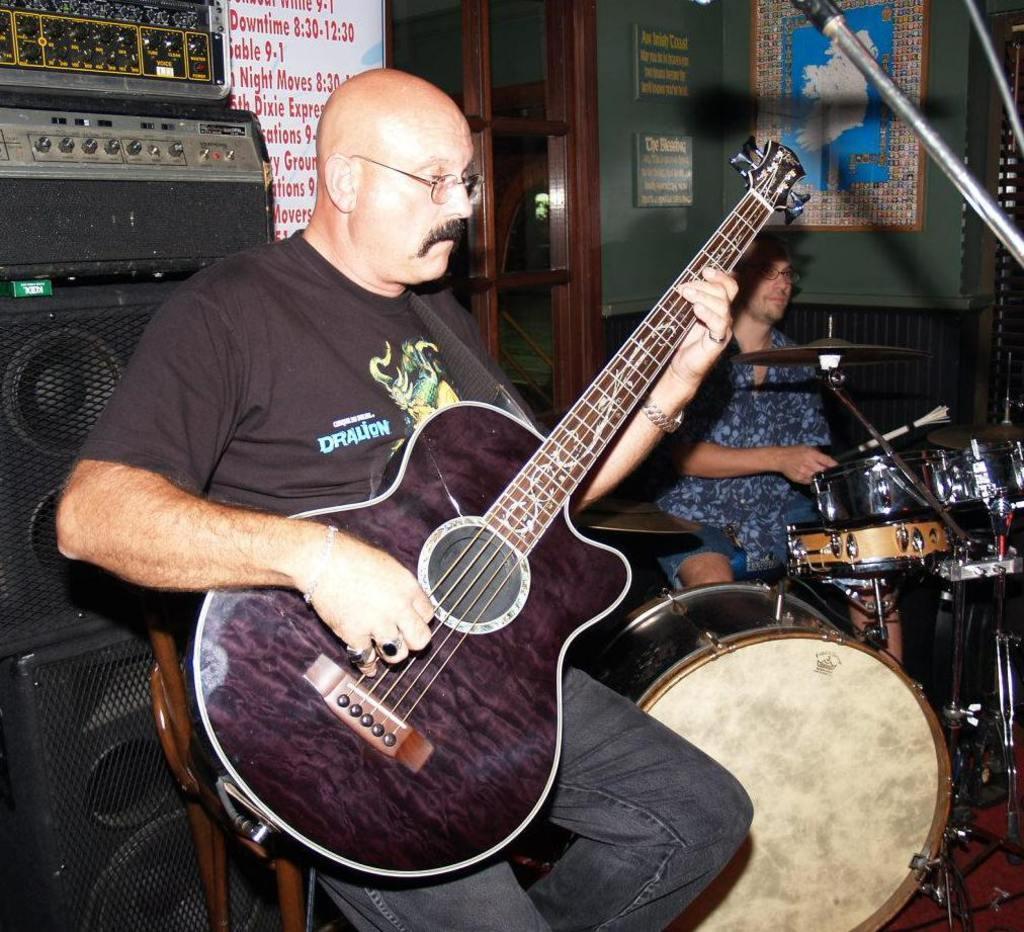Please provide a concise description of this image. In this image i can see is playing guitar in front of a microphone and other man is playing drums. 